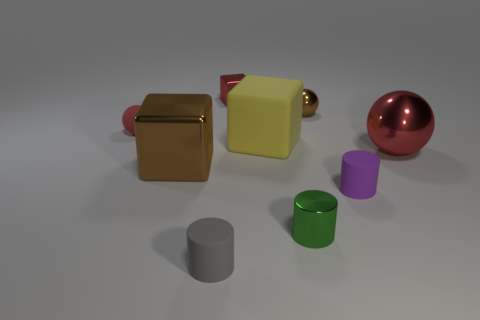Looking at the arrangement of objects, what kind of setting or scenario does this remind you of? The arrangement of the objects in the image evokes a sense of an organized still life composition, reminiscent of abstract or instructional setups used for artistic studies or physical simulations. The positioning and variety of shapes and colors seem intentionally selected for showcasing differences in form, texture, and lighting, creating a visually balanced and educational tableau. 